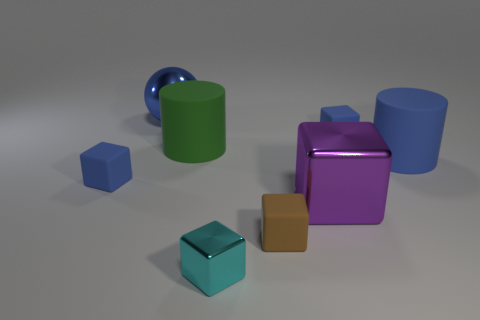Subtract all small brown blocks. How many blocks are left? 4 Subtract all purple blocks. How many blocks are left? 4 Add 2 yellow blocks. How many objects exist? 10 Subtract all brown blocks. Subtract all red cylinders. How many blocks are left? 4 Subtract all cylinders. How many objects are left? 6 Subtract 0 red cylinders. How many objects are left? 8 Subtract all big metal cubes. Subtract all large balls. How many objects are left? 6 Add 3 big balls. How many big balls are left? 4 Add 2 tiny cylinders. How many tiny cylinders exist? 2 